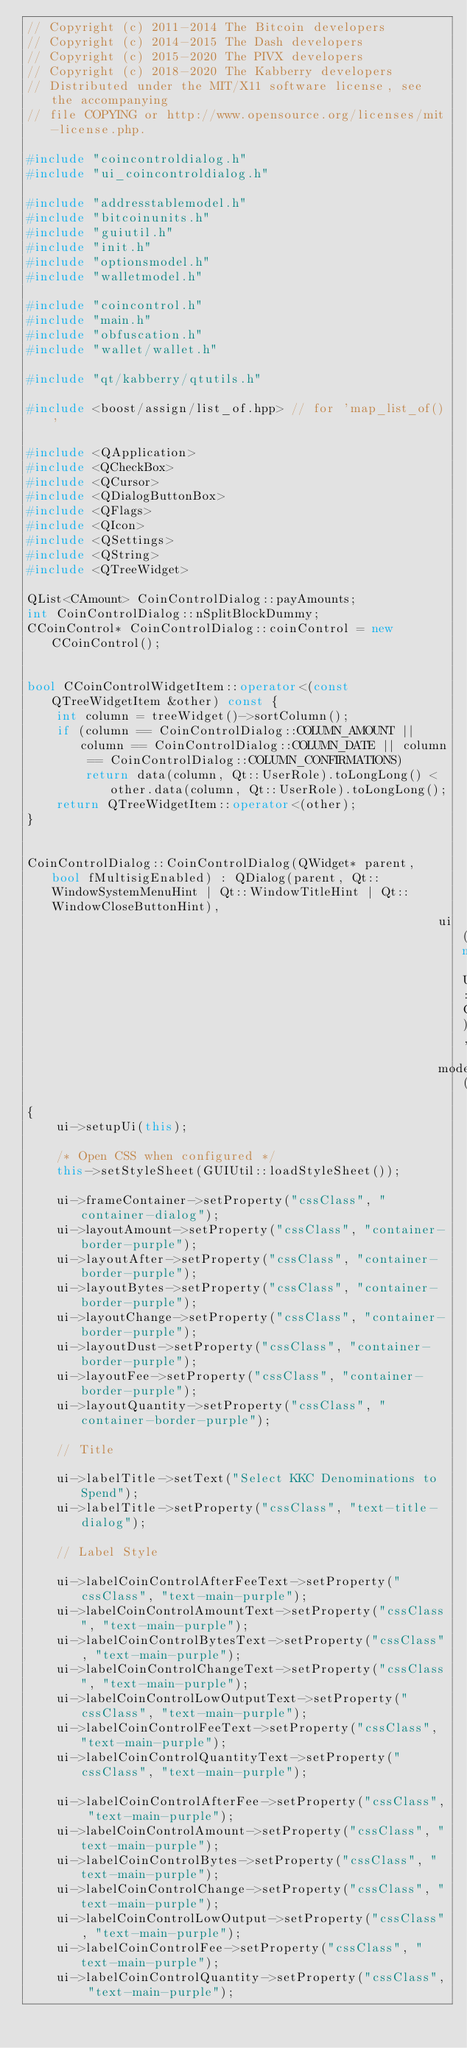Convert code to text. <code><loc_0><loc_0><loc_500><loc_500><_C++_>// Copyright (c) 2011-2014 The Bitcoin developers
// Copyright (c) 2014-2015 The Dash developers
// Copyright (c) 2015-2020 The PIVX developers
// Copyright (c) 2018-2020 The Kabberry developers
// Distributed under the MIT/X11 software license, see the accompanying
// file COPYING or http://www.opensource.org/licenses/mit-license.php.

#include "coincontroldialog.h"
#include "ui_coincontroldialog.h"

#include "addresstablemodel.h"
#include "bitcoinunits.h"
#include "guiutil.h"
#include "init.h"
#include "optionsmodel.h"
#include "walletmodel.h"

#include "coincontrol.h"
#include "main.h"
#include "obfuscation.h"
#include "wallet/wallet.h"

#include "qt/kabberry/qtutils.h"

#include <boost/assign/list_of.hpp> // for 'map_list_of()'

#include <QApplication>
#include <QCheckBox>
#include <QCursor>
#include <QDialogButtonBox>
#include <QFlags>
#include <QIcon>
#include <QSettings>
#include <QString>
#include <QTreeWidget>

QList<CAmount> CoinControlDialog::payAmounts;
int CoinControlDialog::nSplitBlockDummy;
CCoinControl* CoinControlDialog::coinControl = new CCoinControl();


bool CCoinControlWidgetItem::operator<(const QTreeWidgetItem &other) const {
    int column = treeWidget()->sortColumn();
    if (column == CoinControlDialog::COLUMN_AMOUNT || column == CoinControlDialog::COLUMN_DATE || column == CoinControlDialog::COLUMN_CONFIRMATIONS)
        return data(column, Qt::UserRole).toLongLong() < other.data(column, Qt::UserRole).toLongLong();
    return QTreeWidgetItem::operator<(other);
}


CoinControlDialog::CoinControlDialog(QWidget* parent, bool fMultisigEnabled) : QDialog(parent, Qt::WindowSystemMenuHint | Qt::WindowTitleHint | Qt::WindowCloseButtonHint),
                                                        ui(new Ui::CoinControlDialog),
                                                        model(0)
{
    ui->setupUi(this);

    /* Open CSS when configured */
    this->setStyleSheet(GUIUtil::loadStyleSheet());

    ui->frameContainer->setProperty("cssClass", "container-dialog");
    ui->layoutAmount->setProperty("cssClass", "container-border-purple");
    ui->layoutAfter->setProperty("cssClass", "container-border-purple");
    ui->layoutBytes->setProperty("cssClass", "container-border-purple");
    ui->layoutChange->setProperty("cssClass", "container-border-purple");
    ui->layoutDust->setProperty("cssClass", "container-border-purple");
    ui->layoutFee->setProperty("cssClass", "container-border-purple");
    ui->layoutQuantity->setProperty("cssClass", "container-border-purple");

    // Title

    ui->labelTitle->setText("Select KKC Denominations to Spend");
    ui->labelTitle->setProperty("cssClass", "text-title-dialog");

    // Label Style

    ui->labelCoinControlAfterFeeText->setProperty("cssClass", "text-main-purple");
    ui->labelCoinControlAmountText->setProperty("cssClass", "text-main-purple");
    ui->labelCoinControlBytesText->setProperty("cssClass", "text-main-purple");
    ui->labelCoinControlChangeText->setProperty("cssClass", "text-main-purple");
    ui->labelCoinControlLowOutputText->setProperty("cssClass", "text-main-purple");
    ui->labelCoinControlFeeText->setProperty("cssClass", "text-main-purple");
    ui->labelCoinControlQuantityText->setProperty("cssClass", "text-main-purple");

    ui->labelCoinControlAfterFee->setProperty("cssClass", "text-main-purple");
    ui->labelCoinControlAmount->setProperty("cssClass", "text-main-purple");
    ui->labelCoinControlBytes->setProperty("cssClass", "text-main-purple");
    ui->labelCoinControlChange->setProperty("cssClass", "text-main-purple");
    ui->labelCoinControlLowOutput->setProperty("cssClass", "text-main-purple");
    ui->labelCoinControlFee->setProperty("cssClass", "text-main-purple");
    ui->labelCoinControlQuantity->setProperty("cssClass", "text-main-purple");
</code> 